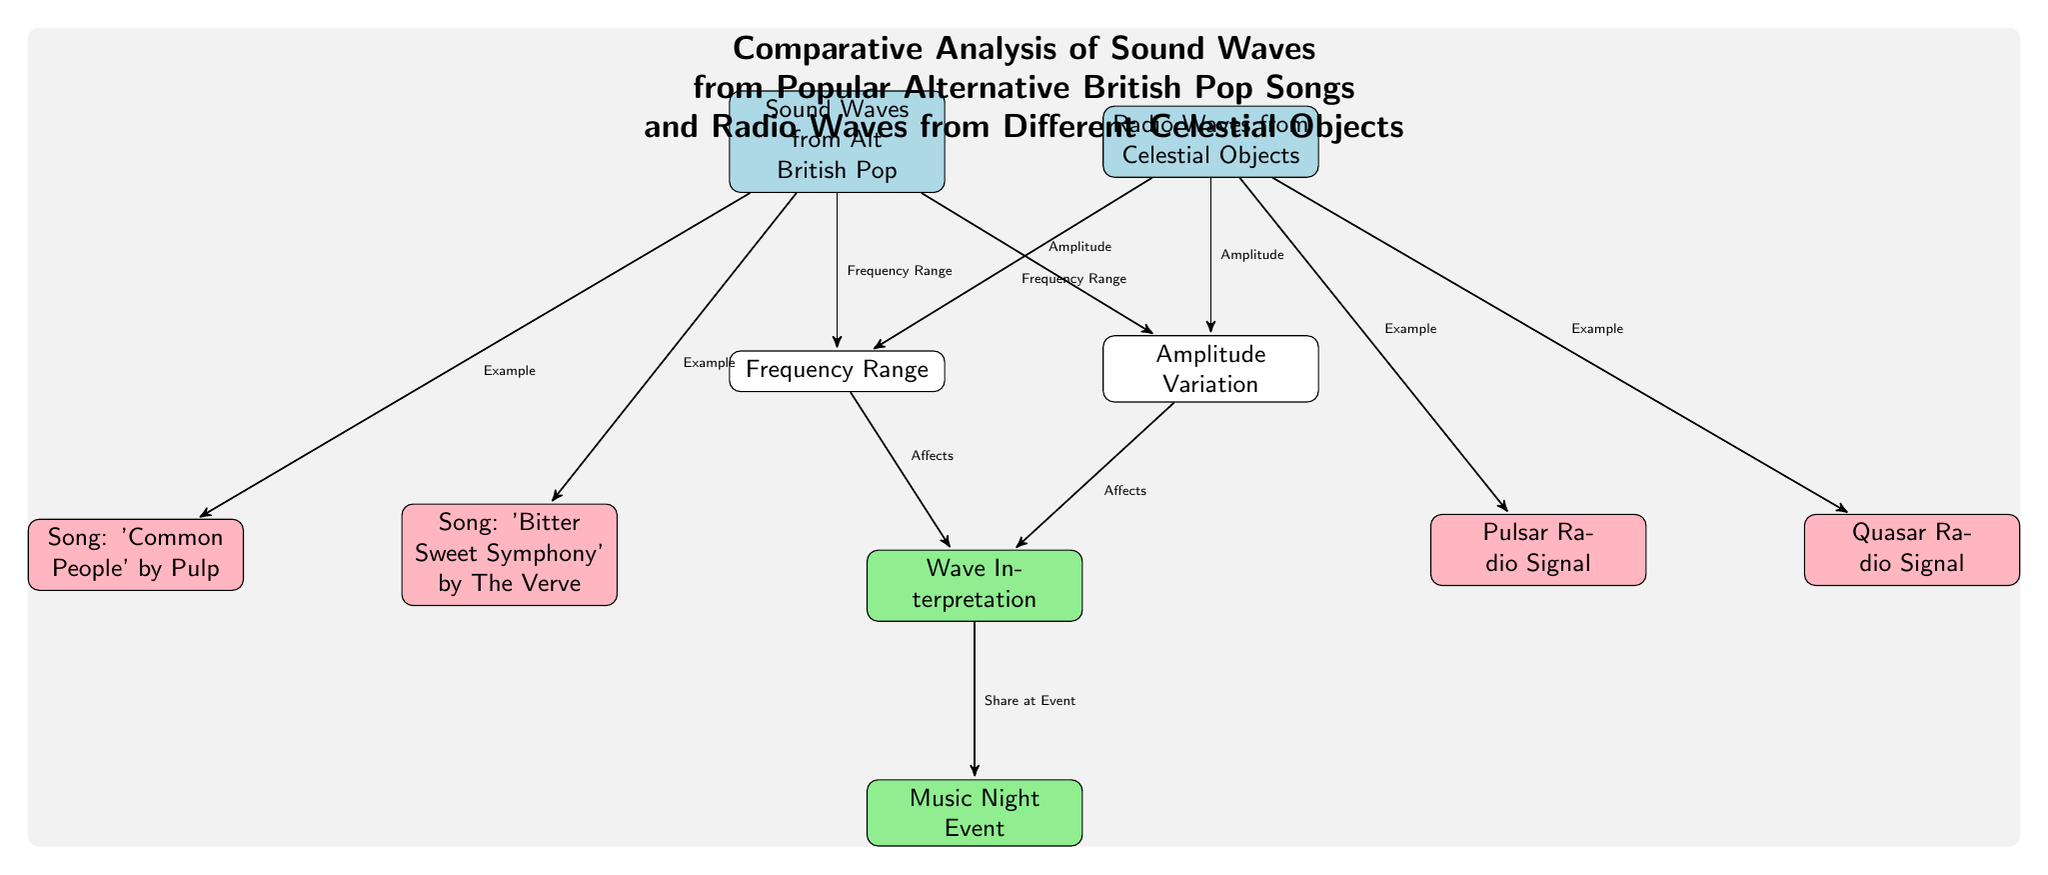What are the names of the two songs shown in the diagram? The songs listed in the diagram are 'Bitter Sweet Symphony' by The Verve and 'Common People' by Pulp. The names are clearly indicated in their respective nodes.
Answer: 'Bitter Sweet Symphony', 'Common People' How many examples of celestial objects are provided in the diagram? The diagram provides two examples of celestial objects: a Pulsar Radio Signal and a Quasar Radio Signal. These are found within the node connected to radio waves.
Answer: 2 What type of wave originates from the British pop songs as per the diagram? The diagram labels the type of wave that originates from the British pop songs as "Sound Waves." This is directly stated in the corresponding node.
Answer: Sound Waves Which aspect is indicated to affect wave interpretation? The two aspects indicated to affect wave interpretation are Frequency Range and Amplitude Variation, both originating from their respective nodes. Each aspect is connected to the Wave Interpretation node.
Answer: Frequency Range, Amplitude Variation What is the overall purpose of the diagram? The overall purpose of the diagram is to conduct a "Comparative Analysis" between sound waves from popular alternative British pop songs and radio waves from celestial objects. This purpose is stated at the title of the diagram.
Answer: Comparative Analysis What is the name of the event mentioned that relates to the data in the diagram? The event related to the data in the diagram is called "Music Night Event." It is connected to the Wave Interpretation node, showing where the interpretation can be shared.
Answer: Music Night Event What color represents sound waves from alternative British pop songs? The color that represents sound waves from alternative British pop songs in the diagram is pink, as defined by the RGB values in the style for those nodes.
Answer: Pink Which celestial object wave is listed first in the diagram? The first celestial object wave listed in the diagram is the Pulsar Radio Signal. It is positioned before the Quasar Radio Signal node in the layout.
Answer: Pulsar Radio Signal 